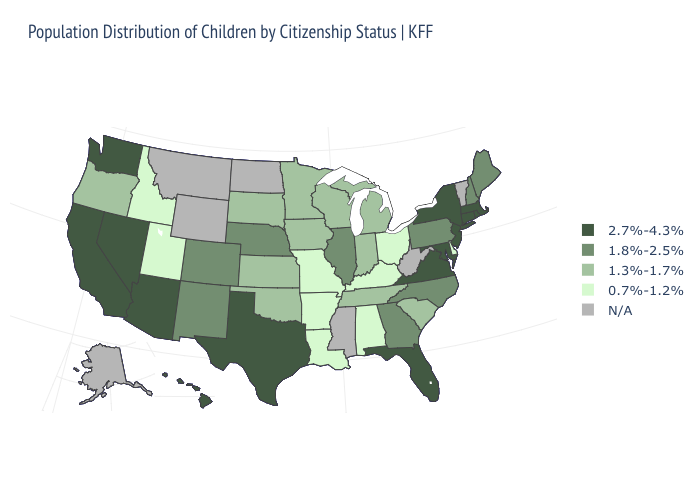What is the value of Massachusetts?
Write a very short answer. 2.7%-4.3%. Does the map have missing data?
Concise answer only. Yes. Does the first symbol in the legend represent the smallest category?
Give a very brief answer. No. Among the states that border Arkansas , does Missouri have the highest value?
Be succinct. No. Name the states that have a value in the range N/A?
Answer briefly. Alaska, Mississippi, Montana, North Dakota, Vermont, West Virginia, Wyoming. Which states have the highest value in the USA?
Concise answer only. Arizona, California, Connecticut, Florida, Hawaii, Maryland, Massachusetts, Nevada, New Jersey, New York, Rhode Island, Texas, Virginia, Washington. What is the highest value in the USA?
Write a very short answer. 2.7%-4.3%. Which states hav the highest value in the West?
Be succinct. Arizona, California, Hawaii, Nevada, Washington. Among the states that border Arkansas , does Missouri have the highest value?
Write a very short answer. No. Does the map have missing data?
Give a very brief answer. Yes. What is the highest value in the USA?
Short answer required. 2.7%-4.3%. What is the lowest value in states that border Illinois?
Answer briefly. 0.7%-1.2%. Does Illinois have the highest value in the MidWest?
Answer briefly. Yes. Does Arkansas have the lowest value in the USA?
Answer briefly. Yes. Does New Jersey have the highest value in the Northeast?
Answer briefly. Yes. 